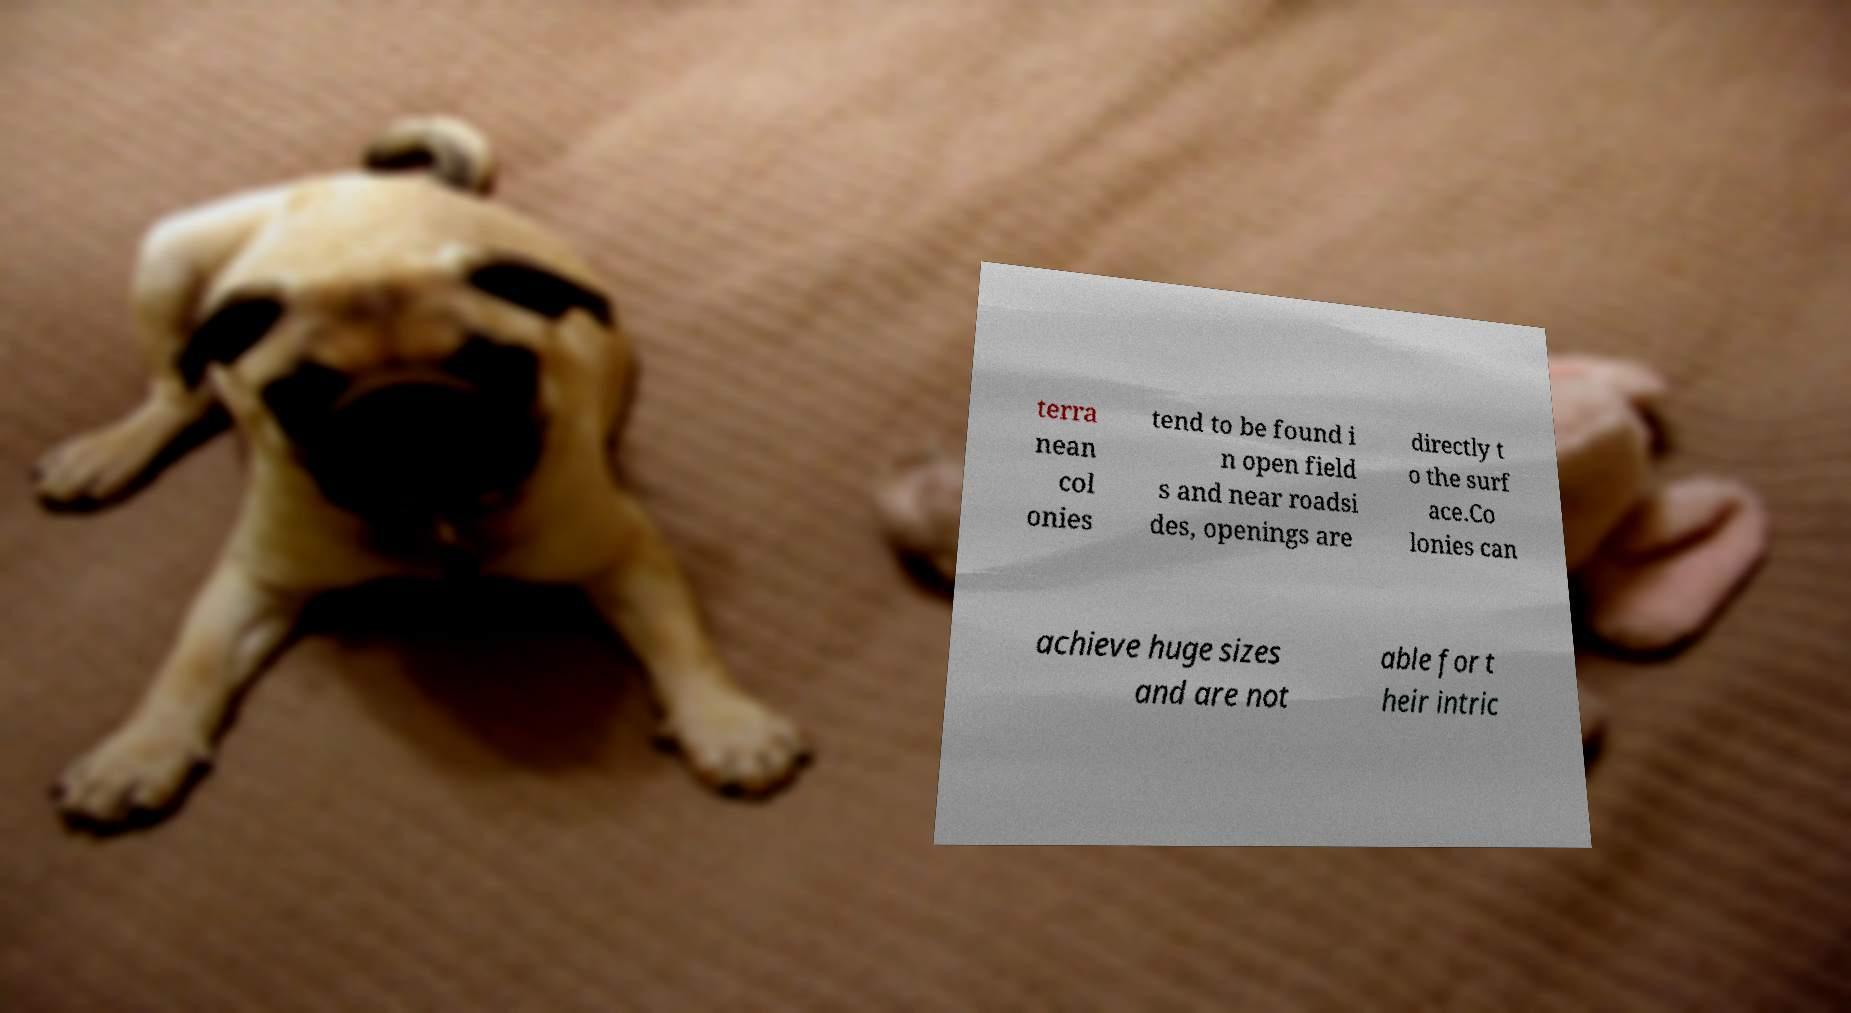Could you extract and type out the text from this image? terra nean col onies tend to be found i n open field s and near roadsi des, openings are directly t o the surf ace.Co lonies can achieve huge sizes and are not able for t heir intric 